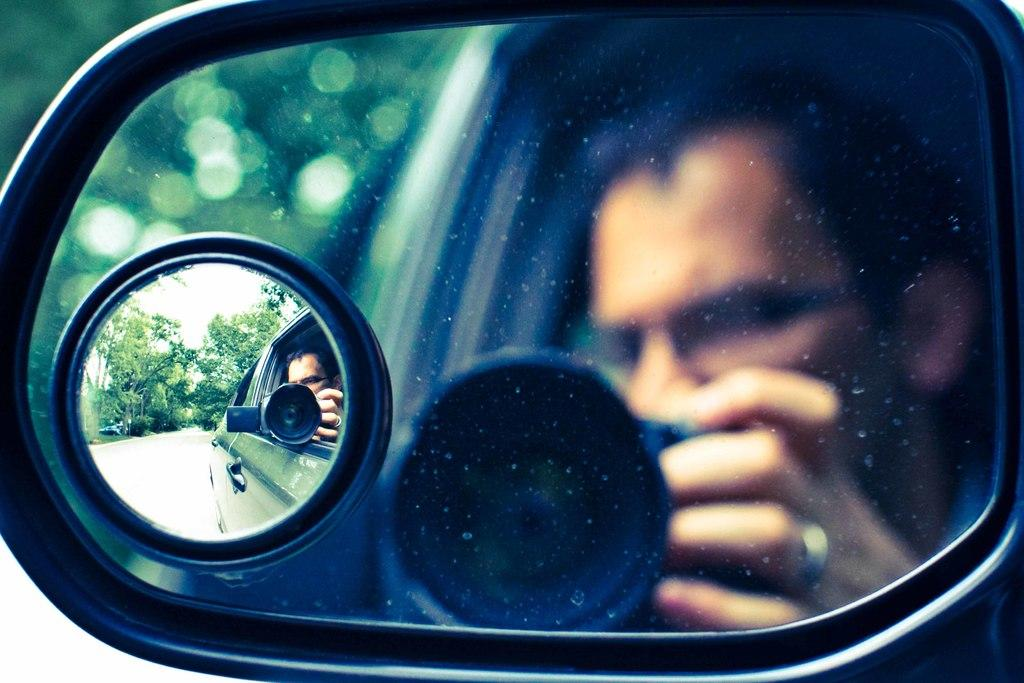What object is the main focus of the image? The main focus of the image is the side mirror of a car. What can be seen in the side mirror? The side mirror reflects a man holding a camera. What is visible in the background of the image? There are trees in the background of the image. What type of insect can be seen crawling on the border of the image? There is no insect present in the image, and there is no border to speak of. 